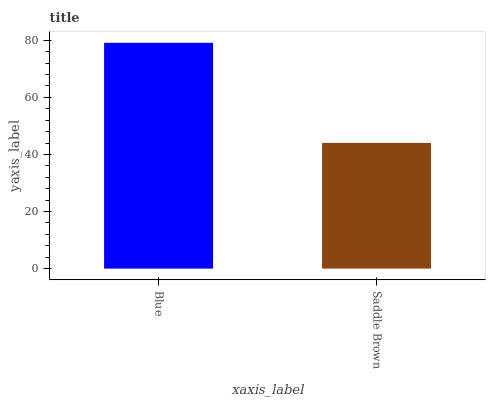Is Blue the maximum?
Answer yes or no. Yes. Is Saddle Brown the maximum?
Answer yes or no. No. Is Blue greater than Saddle Brown?
Answer yes or no. Yes. Is Saddle Brown less than Blue?
Answer yes or no. Yes. Is Saddle Brown greater than Blue?
Answer yes or no. No. Is Blue less than Saddle Brown?
Answer yes or no. No. Is Blue the high median?
Answer yes or no. Yes. Is Saddle Brown the low median?
Answer yes or no. Yes. Is Saddle Brown the high median?
Answer yes or no. No. Is Blue the low median?
Answer yes or no. No. 